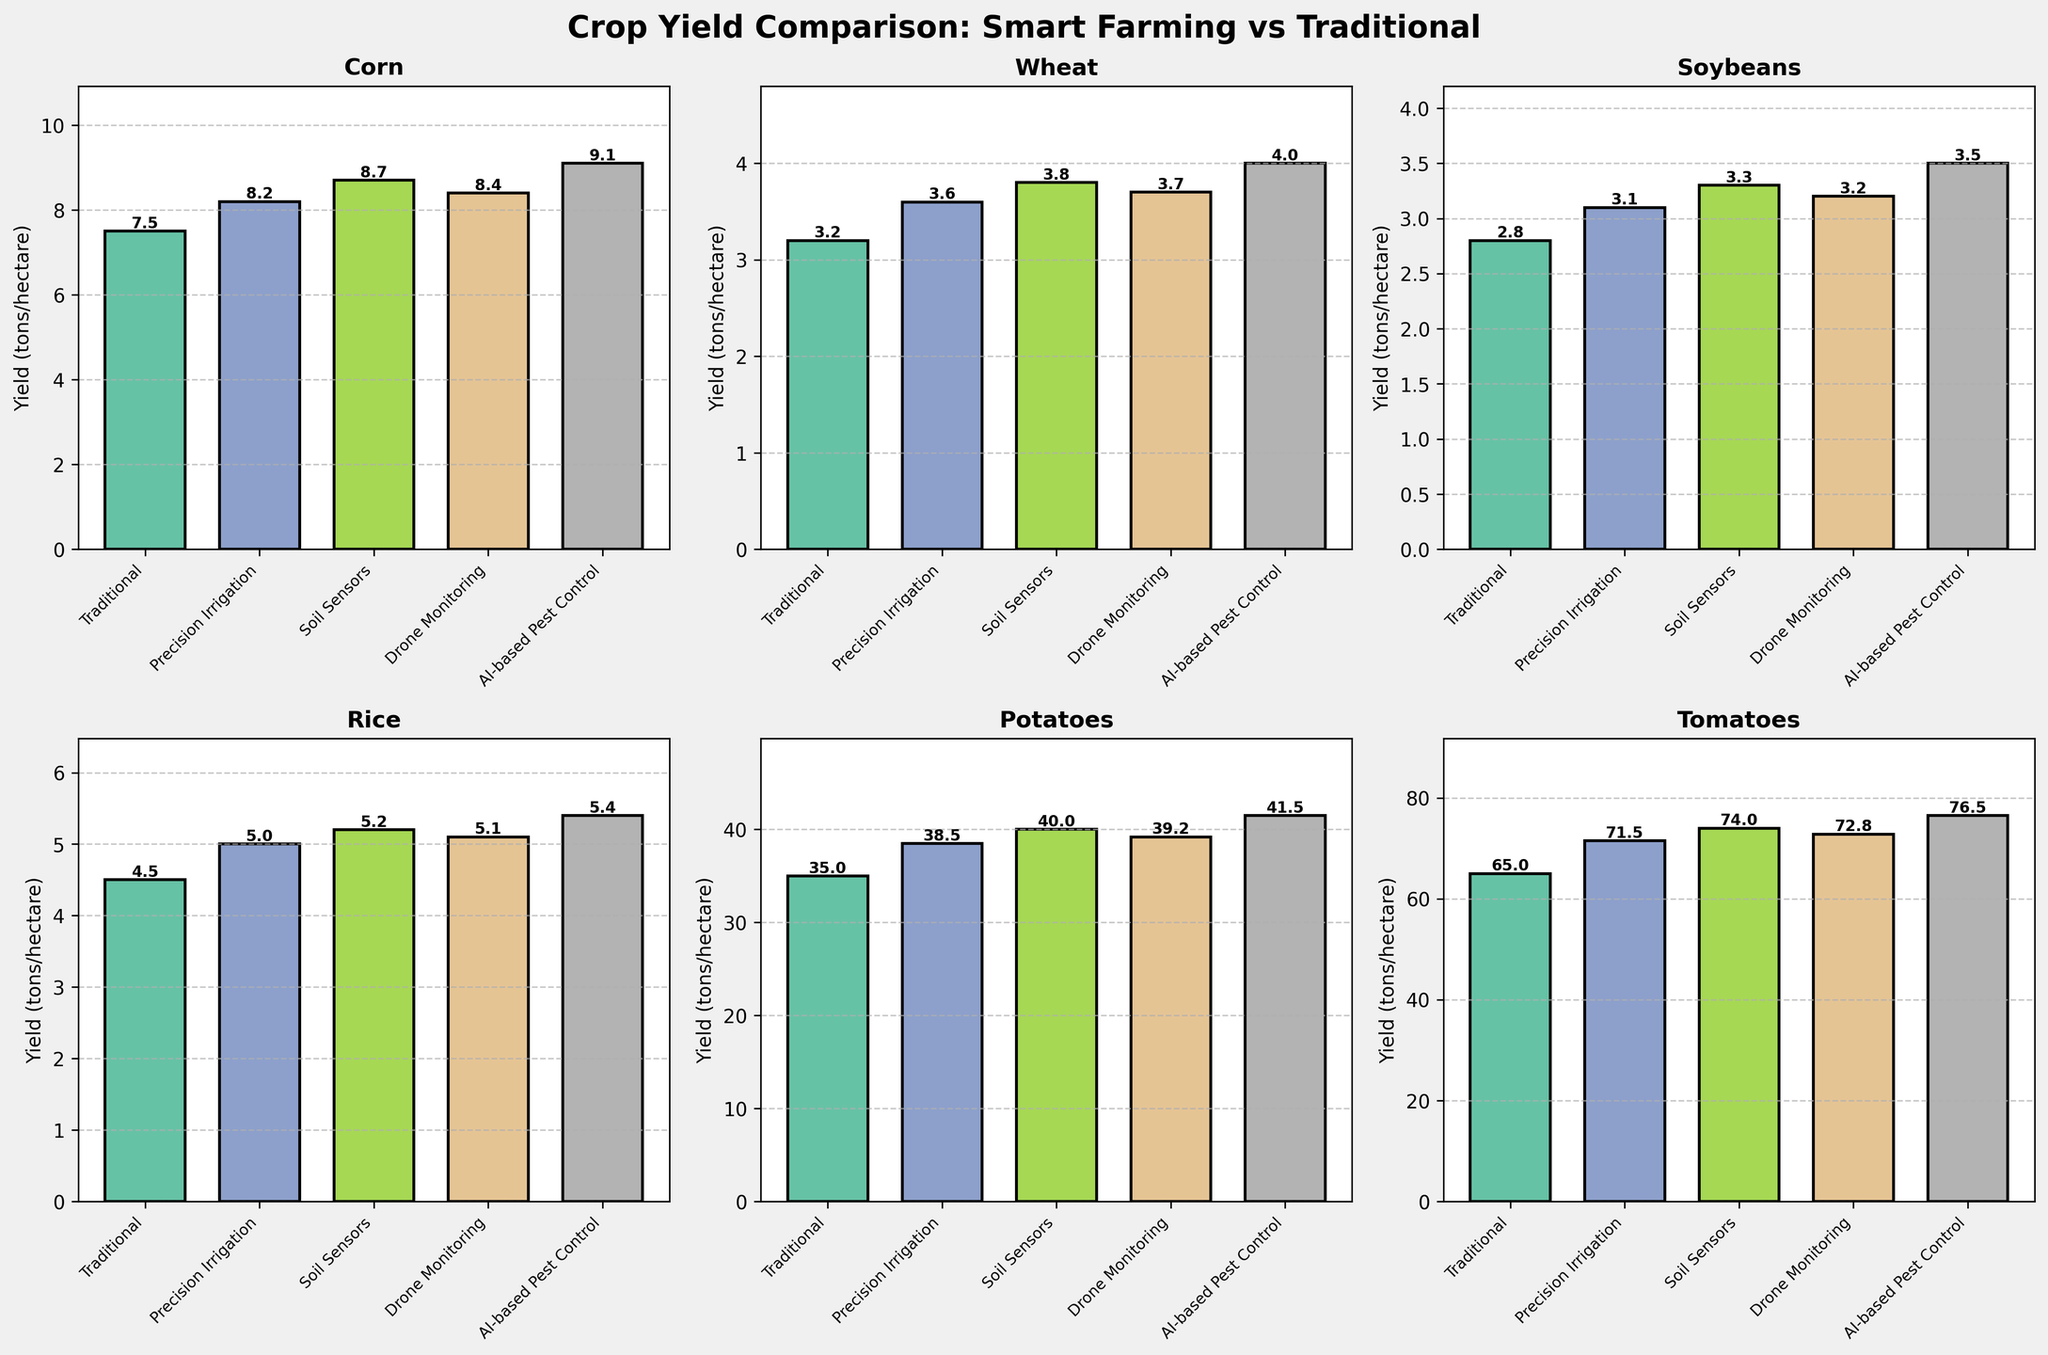What's the title of the figure? The title is written at the top of the figure and summarizes the comparison of crop yields using different farming techniques.
Answer: Crop Yield Comparison: Smart Farming vs Traditional How many cropping techniques are compared in each plot? Each subplot shows five different cropping techniques, which are listed along the x-axis.
Answer: 5 Which crop shows the highest yield using AI-based Pest Control? By comparing the yields represented by the tallest bars in each subplot, the highest yield for AI-based Pest Control is seen in the Tomatoes plot.
Answer: Tomatoes What's the yield difference between Traditional and Precision Irrigation for Potatoes? For Potatoes, identify the bar corresponding to Traditional technique (35.0) and Precision Irrigation (38.5), then subtract the former from the latter.
Answer: 3.5 tons/hectare Which farming technique results in the highest yield for Corn? Check the heights of the bars for each technique in the Corn subplot, the highest yield is for AI-based Pest Control.
Answer: AI-based Pest Control What is the average yield across all techniques for Soybeans? Sum the yields for Soybeans in each technique (2.8, 3.1, 3.3, 3.2, 3.5) and divide by the number of techniques (5). Calculation: (2.8 + 3.1 + 3.3 + 3.2 + 3.5) / 5.
Answer: 3.18 tons/hectare Is the yield for Drone Monitoring always higher than Traditional? Compare the bars for Drone Monitoring and Traditional techniques in each subplot. In each case (Corn, Wheat, Soybeans, Rice, Potatoes, Tomatoes), Drone Monitoring has a higher yield.
Answer: Yes Which crop shows the smallest yield improvement using Soil Sensors over Traditional farming? Calculate the yield differences between Soil Sensors and Traditional techniques for each crop. Soybeans has the smallest difference: 3.3 - 2.8 = 0.5 tons/hectare.
Answer: Soybeans What is the median yield value for Rice across all techniques? List the yield values for Rice (4.5, 5.0, 5.2, 5.1, 5.4), sort them (4.5, 5.0, 5.1, 5.2, 5.4), and identify the middle value.
Answer: 5.1 tons/hectare 